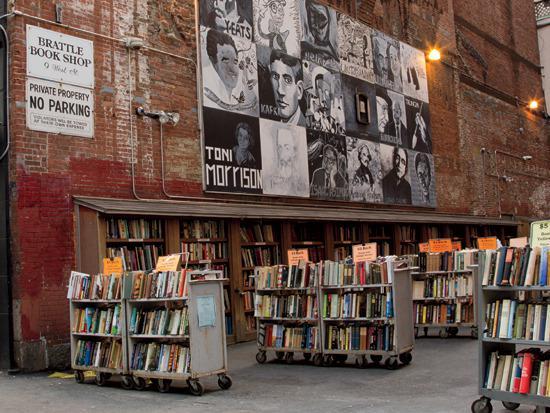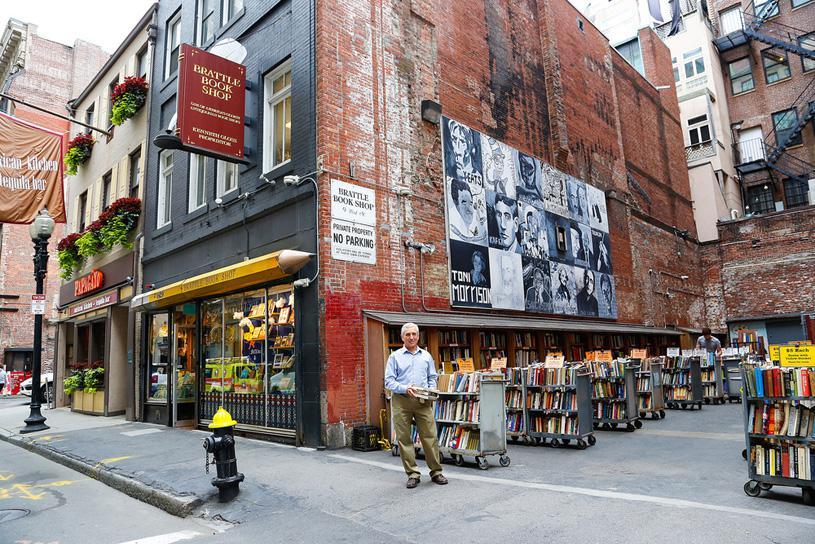The first image is the image on the left, the second image is the image on the right. Considering the images on both sides, is "A man in tan pants is standing up near a building in the image on the right." valid? Answer yes or no. Yes. The first image is the image on the left, the second image is the image on the right. Analyze the images presented: Is the assertion "An image shows a yellow sharpened pencil shape above shop windows and below a projecting reddish sign." valid? Answer yes or no. Yes. 